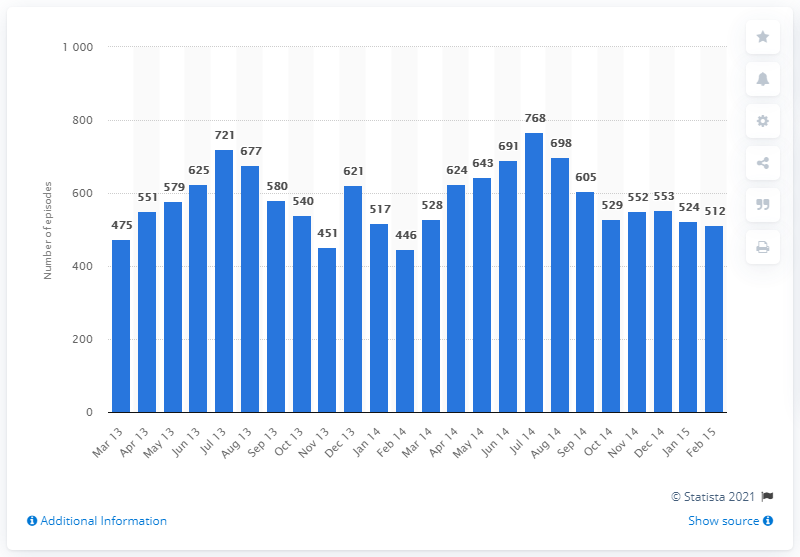Draw attention to some important aspects in this diagram. In December 2014, there were 553 hospital admissions resulting from dog bites or strikes. 